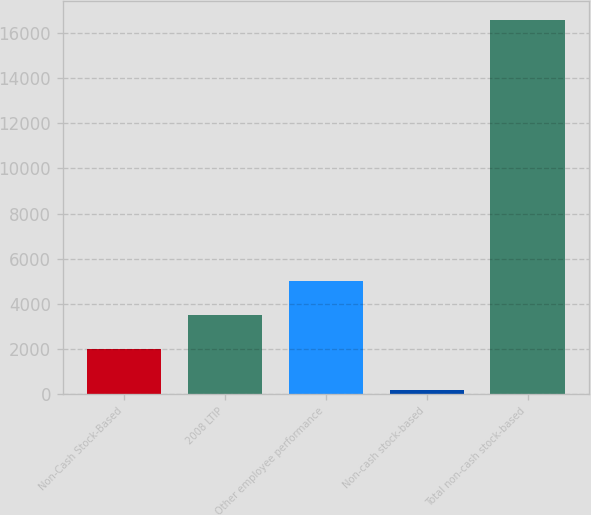Convert chart. <chart><loc_0><loc_0><loc_500><loc_500><bar_chart><fcel>Non-Cash Stock-Based<fcel>2008 LTIP<fcel>Other employee performance<fcel>Non-cash stock-based<fcel>Total non-cash stock-based<nl><fcel>2013<fcel>3520.1<fcel>5027.2<fcel>182<fcel>16578.1<nl></chart> 